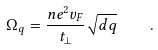Convert formula to latex. <formula><loc_0><loc_0><loc_500><loc_500>\Omega _ { q } = \frac { n e ^ { 2 } v _ { F } } { t _ { \perp } } \sqrt { d q } \quad .</formula> 